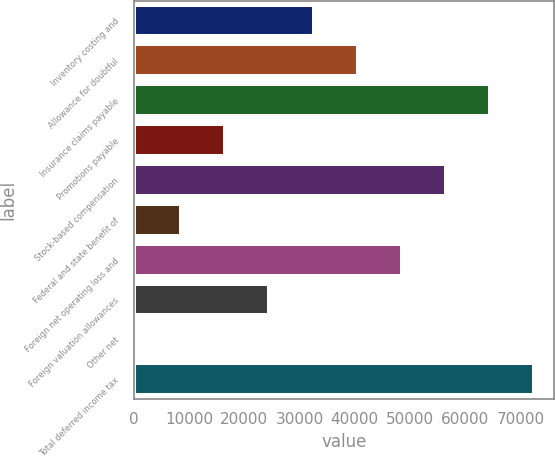<chart> <loc_0><loc_0><loc_500><loc_500><bar_chart><fcel>Inventory costing and<fcel>Allowance for doubtful<fcel>Insurance claims payable<fcel>Promotions payable<fcel>Stock-based compensation<fcel>Federal and state benefit of<fcel>Foreign net operating loss and<fcel>Foreign valuation allowances<fcel>Other net<fcel>Total deferred income tax<nl><fcel>32538.4<fcel>40525<fcel>64484.8<fcel>16565.2<fcel>56498.2<fcel>8578.6<fcel>48511.6<fcel>24551.8<fcel>592<fcel>72471.4<nl></chart> 